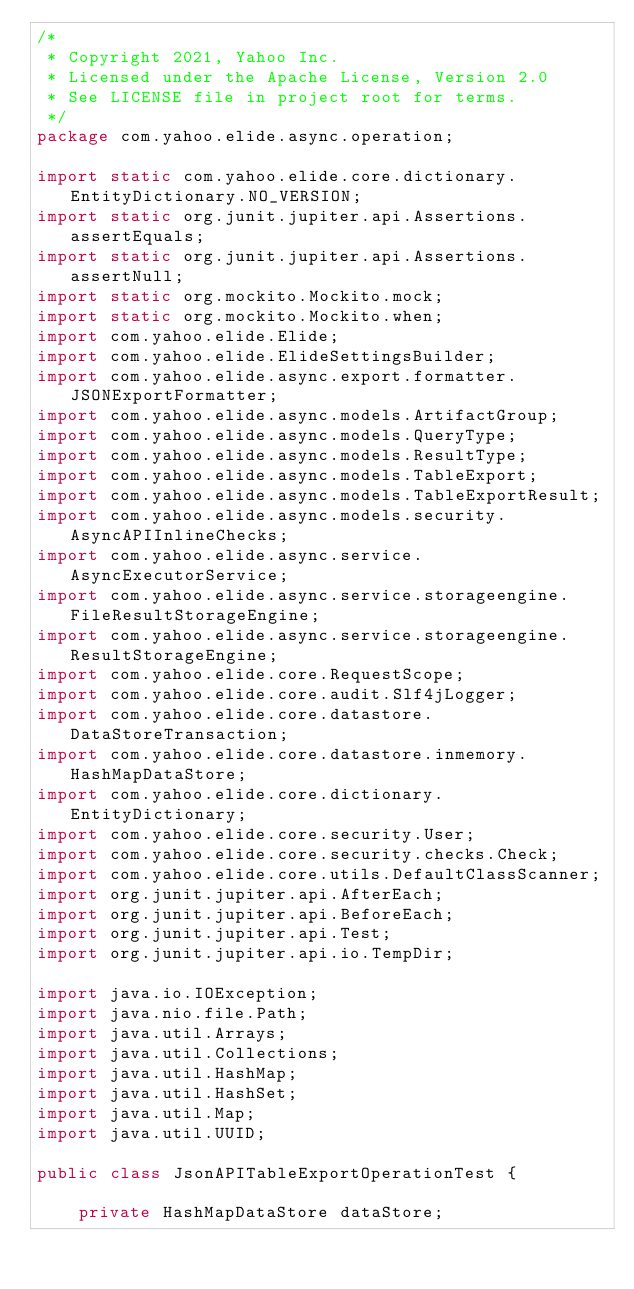<code> <loc_0><loc_0><loc_500><loc_500><_Java_>/*
 * Copyright 2021, Yahoo Inc.
 * Licensed under the Apache License, Version 2.0
 * See LICENSE file in project root for terms.
 */
package com.yahoo.elide.async.operation;

import static com.yahoo.elide.core.dictionary.EntityDictionary.NO_VERSION;
import static org.junit.jupiter.api.Assertions.assertEquals;
import static org.junit.jupiter.api.Assertions.assertNull;
import static org.mockito.Mockito.mock;
import static org.mockito.Mockito.when;
import com.yahoo.elide.Elide;
import com.yahoo.elide.ElideSettingsBuilder;
import com.yahoo.elide.async.export.formatter.JSONExportFormatter;
import com.yahoo.elide.async.models.ArtifactGroup;
import com.yahoo.elide.async.models.QueryType;
import com.yahoo.elide.async.models.ResultType;
import com.yahoo.elide.async.models.TableExport;
import com.yahoo.elide.async.models.TableExportResult;
import com.yahoo.elide.async.models.security.AsyncAPIInlineChecks;
import com.yahoo.elide.async.service.AsyncExecutorService;
import com.yahoo.elide.async.service.storageengine.FileResultStorageEngine;
import com.yahoo.elide.async.service.storageengine.ResultStorageEngine;
import com.yahoo.elide.core.RequestScope;
import com.yahoo.elide.core.audit.Slf4jLogger;
import com.yahoo.elide.core.datastore.DataStoreTransaction;
import com.yahoo.elide.core.datastore.inmemory.HashMapDataStore;
import com.yahoo.elide.core.dictionary.EntityDictionary;
import com.yahoo.elide.core.security.User;
import com.yahoo.elide.core.security.checks.Check;
import com.yahoo.elide.core.utils.DefaultClassScanner;
import org.junit.jupiter.api.AfterEach;
import org.junit.jupiter.api.BeforeEach;
import org.junit.jupiter.api.Test;
import org.junit.jupiter.api.io.TempDir;

import java.io.IOException;
import java.nio.file.Path;
import java.util.Arrays;
import java.util.Collections;
import java.util.HashMap;
import java.util.HashSet;
import java.util.Map;
import java.util.UUID;

public class JsonAPITableExportOperationTest {

    private HashMapDataStore dataStore;</code> 